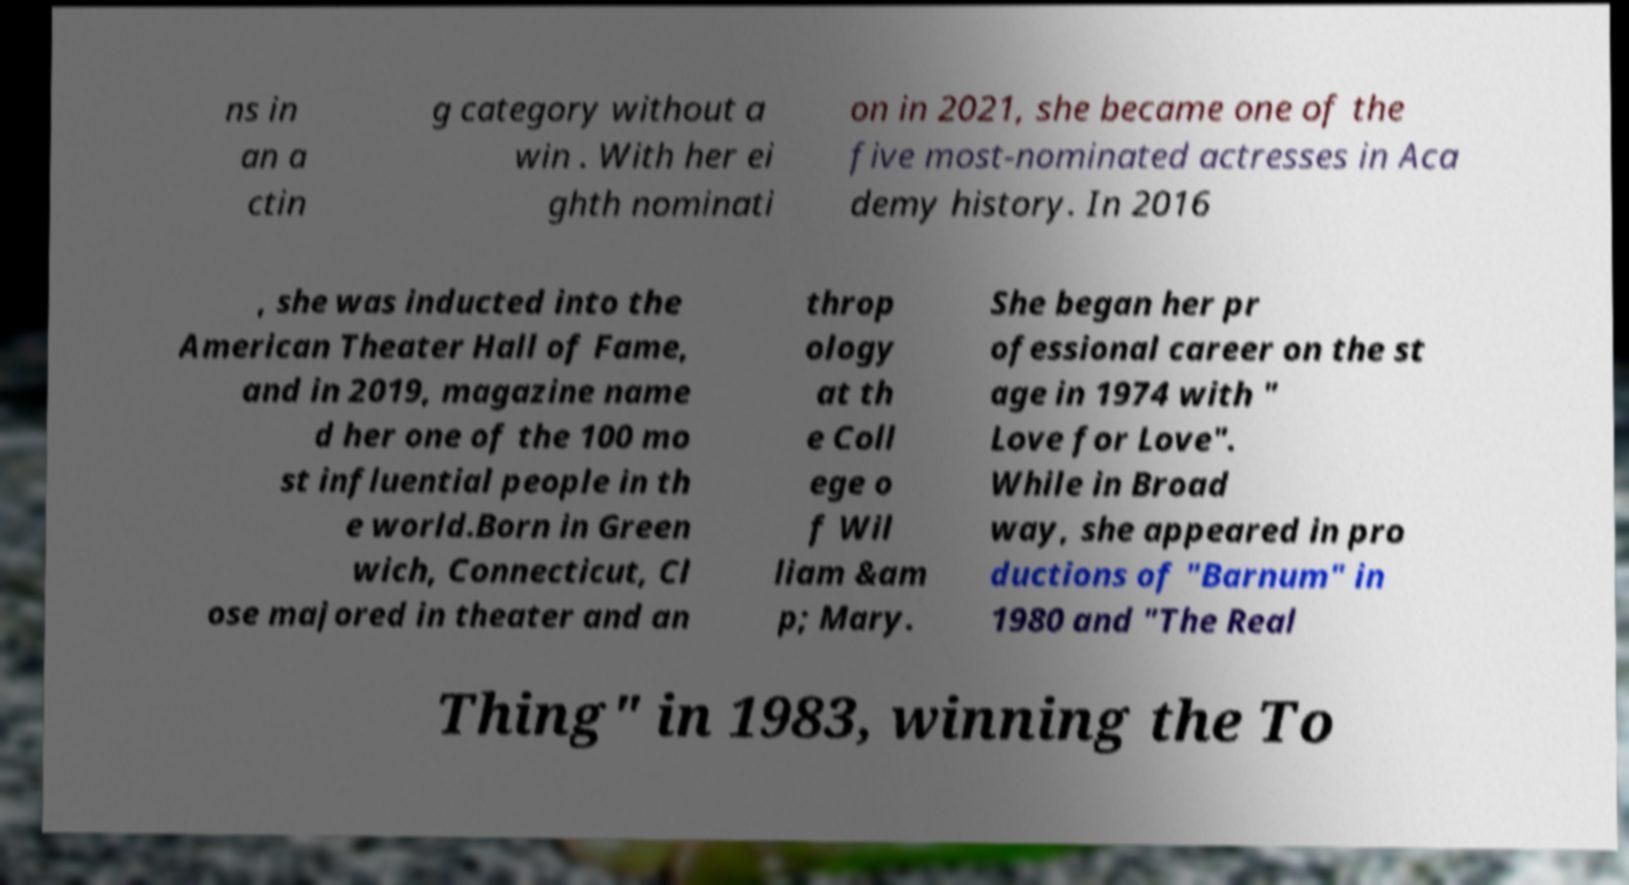Please read and relay the text visible in this image. What does it say? ns in an a ctin g category without a win . With her ei ghth nominati on in 2021, she became one of the five most-nominated actresses in Aca demy history. In 2016 , she was inducted into the American Theater Hall of Fame, and in 2019, magazine name d her one of the 100 mo st influential people in th e world.Born in Green wich, Connecticut, Cl ose majored in theater and an throp ology at th e Coll ege o f Wil liam &am p; Mary. She began her pr ofessional career on the st age in 1974 with " Love for Love". While in Broad way, she appeared in pro ductions of "Barnum" in 1980 and "The Real Thing" in 1983, winning the To 